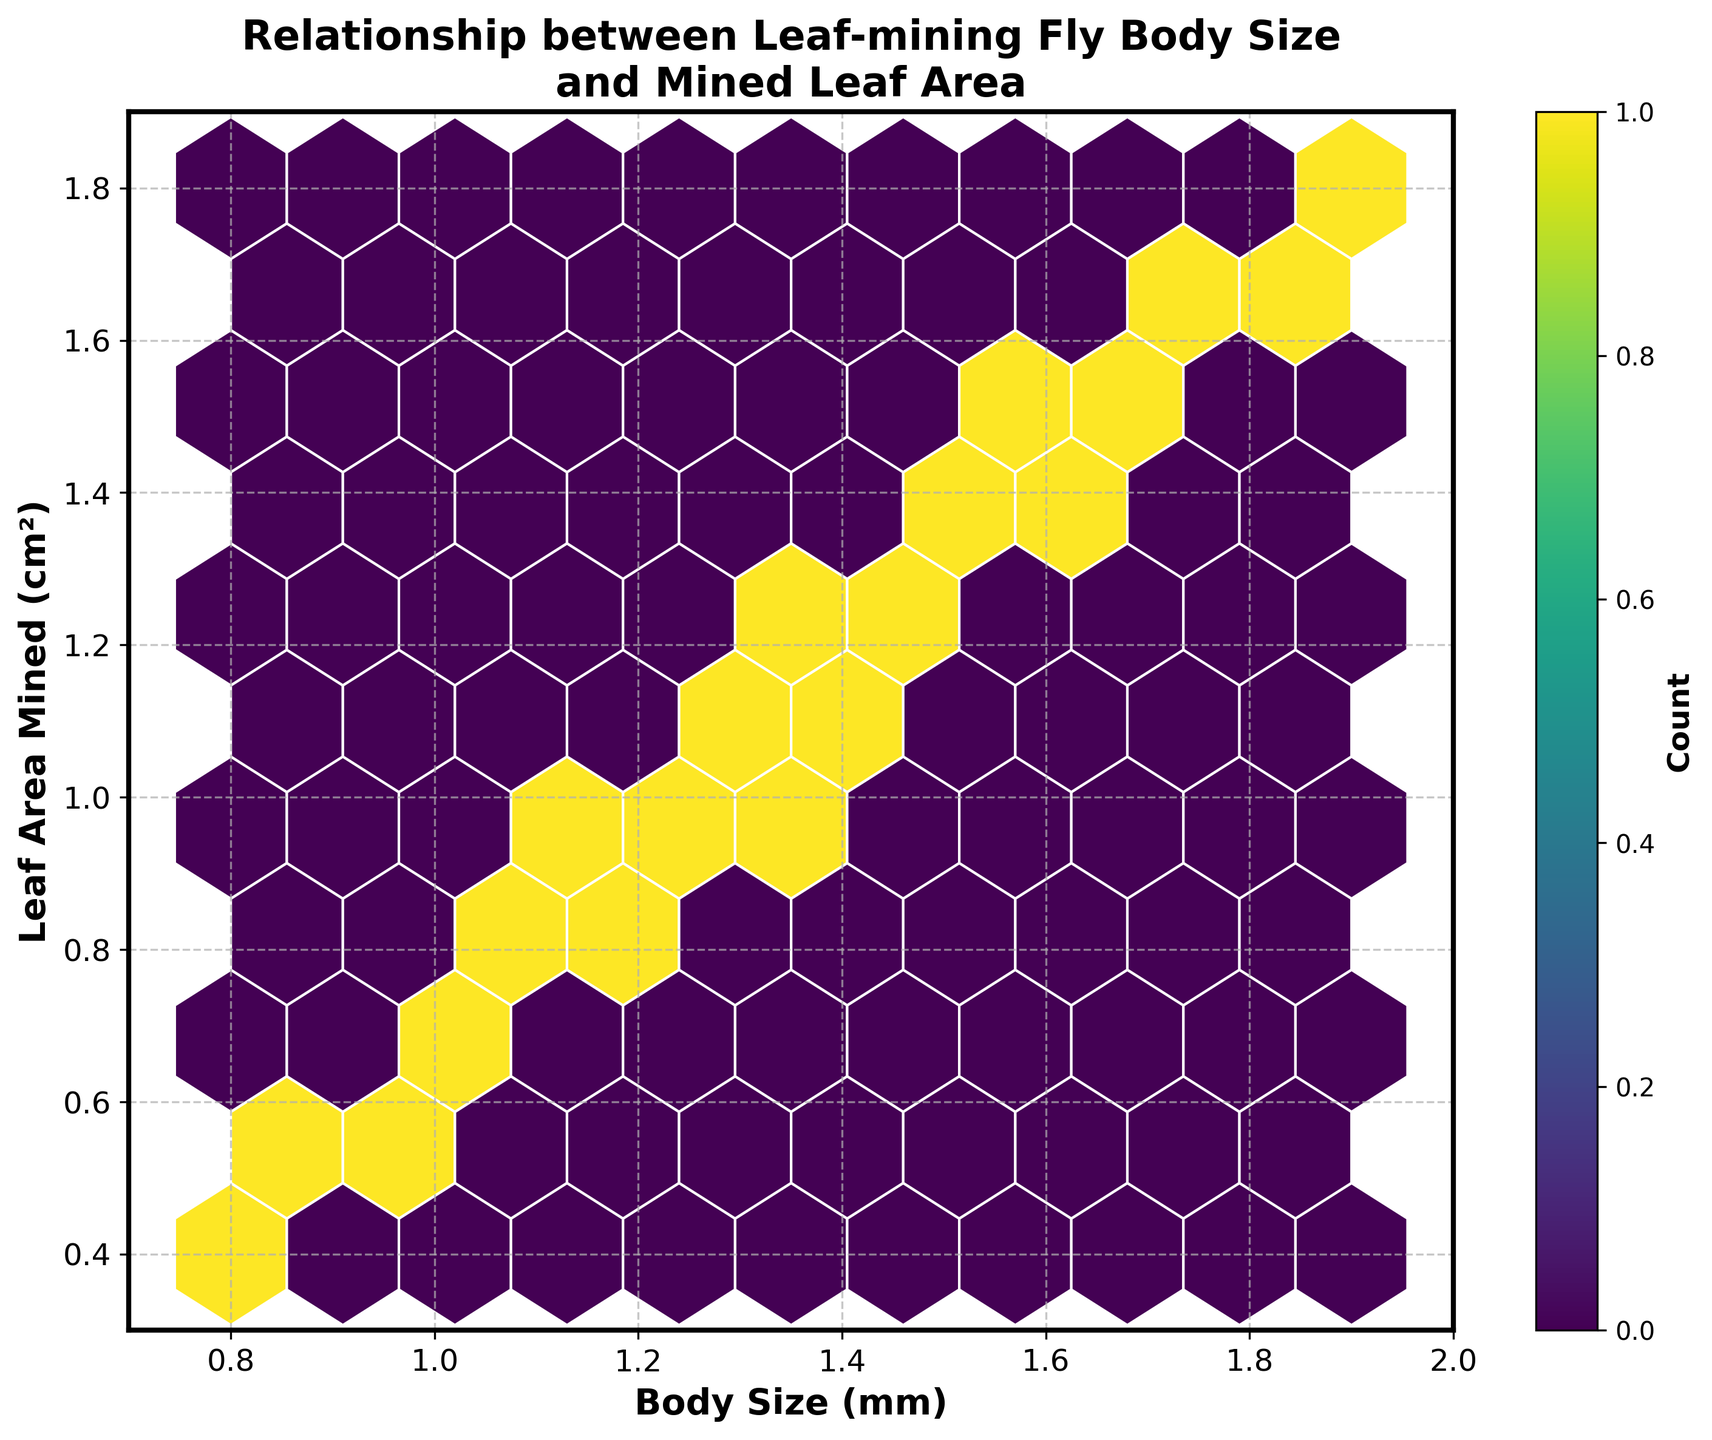What is the title of the figure? The title is often located at the top of the figure and in this plot, it's designed to stand out slightly with a larger font size and bold format. The title is "Relationship between Leaf-mining Fly Body Size and Mined Leaf Area".
Answer: Relationship between Leaf-mining Fly Body Size and Mined Leaf Area Which axis represents the body size of the leaf-mining flies? Observing the x-axis label, the axis representing the body size is labeled as "Body Size (mm)". This label indicates the variable plotted along the horizontal axis.
Answer: x-axis What colors are used in the hexbin plot to represent different counts? The figure uses the 'viridis' colormap from matplotlib. In this colormap, colors range from dark blue for lower bin counts to bright yellow for higher bin counts, as indicated by the colorbar on the right side of the plot.
Answer: Dark blue to bright yellow What is the range of body sizes visualized on the x-axis? The x-axis in the plot is labeled with size values, ranging from approximately 0.7 to 2.0 mm. The axis limits can be seen from the figure’s axis ticks.
Answer: 0.7 to 2.0 mm Which range of the y-axis values is shown in the plot? The y-axis is labeled with leaf area values, ranging from approximately 0.3 to 1.9 cm². Axis limits can be inferred by observing the axis ticks and their placement.
Answer: 0.3 to 1.9 cm² Is there a visible relationship between body size and leaf area mined? Observing the overall clustering and spread of hexagons, it can be seen that there's a positive relationship; as the body size increases, the mined leaf area also tends to increase.
Answer: Yes, positive relationship How many hexagons are mostly colored in bright yellow, indicating higher counts? Based on the colormap and color intensity, bright yellow hexagons indicate higher point concentrations. There is one prominent bright yellow hexagon in the plot, showcasing the highest density region.
Answer: One Between which body size and leaf area values does the highest density of data points occur? The highest density, represented by the bright yellow hexagon, appears around a body size of about 1.5 mm and leaf area mined of around 1.3 cm². Observing the center of the bright yellow hexagon provides these values.
Answer: Approximately 1.5 mm, 1.3 cm² Are there more data points around body sizes of 1.0 mm or 1.8 mm? By comparing the density and color of hexagons in these regions, the area around 1.0 mm is less dense (darker) than around 1.8 mm. Hence, more data points are clustered near 1.8 mm.
Answer: Around 1.8 mm Which leaf area mined value shows more variation in the body size of flies? Analyzing the hexbin spread across different body sizes for varied leaf areas reveals that around 1.0 to 1.1 cm² mined leaf area has a higher variation in body sizes, ranging approximately from 0.9 mm to 1.6 mm.
Answer: Around 1.0 to 1.1 cm² 